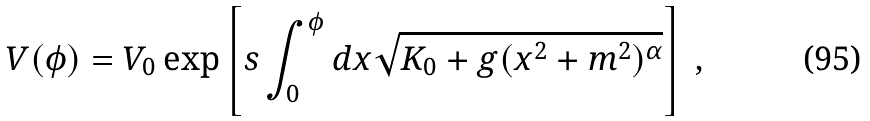<formula> <loc_0><loc_0><loc_500><loc_500>V ( \phi ) = V _ { 0 } \exp \left [ s \int _ { 0 } ^ { \phi } d x \sqrt { K _ { 0 } + g ( x ^ { 2 } + m ^ { 2 } ) ^ { \alpha } } \right ] \ ,</formula> 